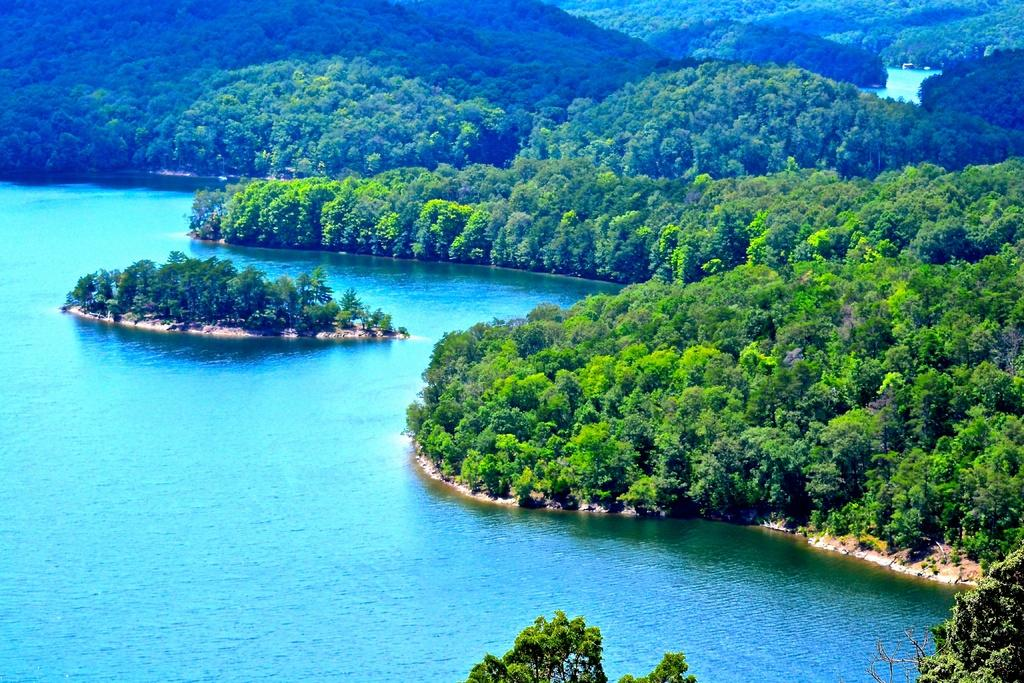What is visible in the image? Water is visible in the image. What can be seen in the background of the image? There are trees in the background of the image. What type of toy is floating in the water in the image? There is no toy present in the image; only water and trees are visible. 